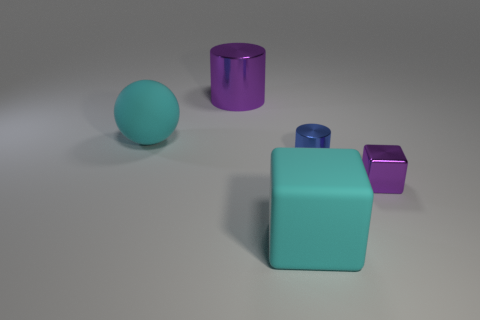What size is the thing that is in front of the large purple cylinder and left of the matte block?
Ensure brevity in your answer.  Large. How many big objects are shiny objects or rubber things?
Provide a short and direct response. 3. There is a purple object in front of the large purple metal cylinder; what shape is it?
Offer a very short reply. Cube. How many small brown metallic things are there?
Your response must be concise. 0. Is the big cyan ball made of the same material as the small blue thing?
Make the answer very short. No. Are there more small purple objects that are to the right of the big purple cylinder than big purple shiny blocks?
Provide a short and direct response. Yes. How many objects are small purple metal cylinders or matte things in front of the large cyan sphere?
Your response must be concise. 1. Are there more cyan rubber spheres that are in front of the tiny blue cylinder than purple metallic things in front of the purple cylinder?
Ensure brevity in your answer.  No. There is a large cylinder that is behind the large cyan cube that is to the left of the purple metal thing in front of the large purple object; what is its material?
Offer a terse response. Metal. The blue object that is the same material as the small purple object is what shape?
Keep it short and to the point. Cylinder. 